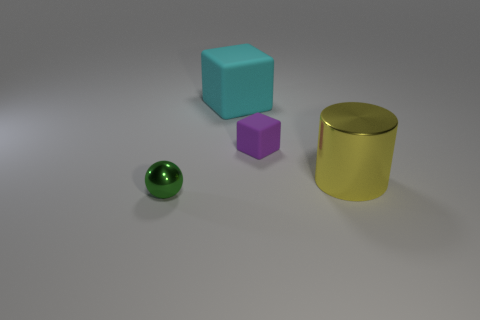Add 2 green things. How many objects exist? 6 Subtract all cyan cubes. How many cubes are left? 1 Subtract 1 cylinders. How many cylinders are left? 0 Subtract all cyan blocks. How many yellow balls are left? 0 Add 3 small things. How many small things are left? 5 Add 3 green objects. How many green objects exist? 4 Subtract 0 gray blocks. How many objects are left? 4 Subtract all cylinders. How many objects are left? 3 Subtract all purple blocks. Subtract all red balls. How many blocks are left? 1 Subtract all red rubber blocks. Subtract all big rubber objects. How many objects are left? 3 